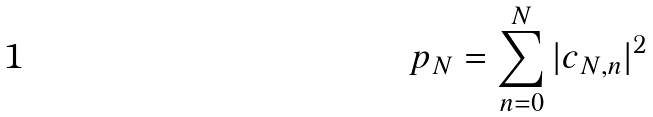<formula> <loc_0><loc_0><loc_500><loc_500>p _ { N } = \sum _ { n = 0 } ^ { N } | c _ { N , n } | ^ { 2 }</formula> 